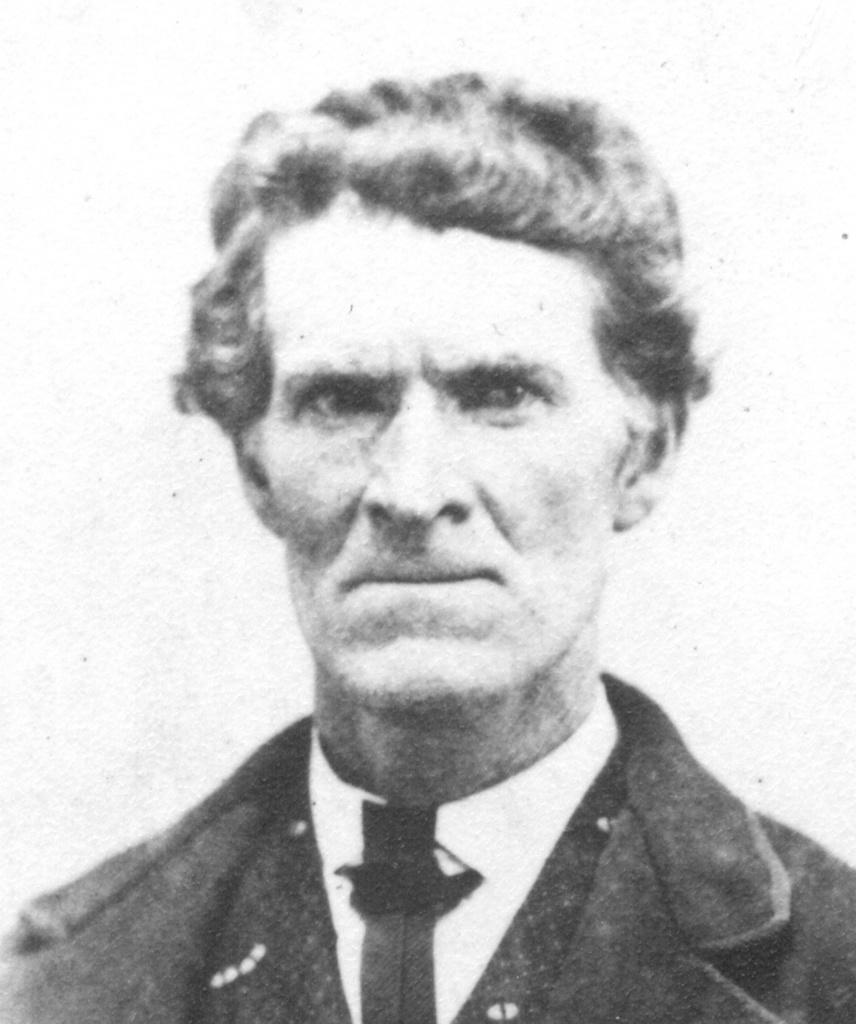What is the color scheme of the image? The image is black and white. Who is the main subject in the image? There is a man in the center of the image. What is the man wearing in the image? The man is wearing a coat and a tie. What can be seen in the background of the image? There is a wall in the background of the image. How many dolls are sitting on the man's shoulders in the image? There are no dolls present in the image. Can you see any bats flying around the man in the image? There are no bats visible in the image. 